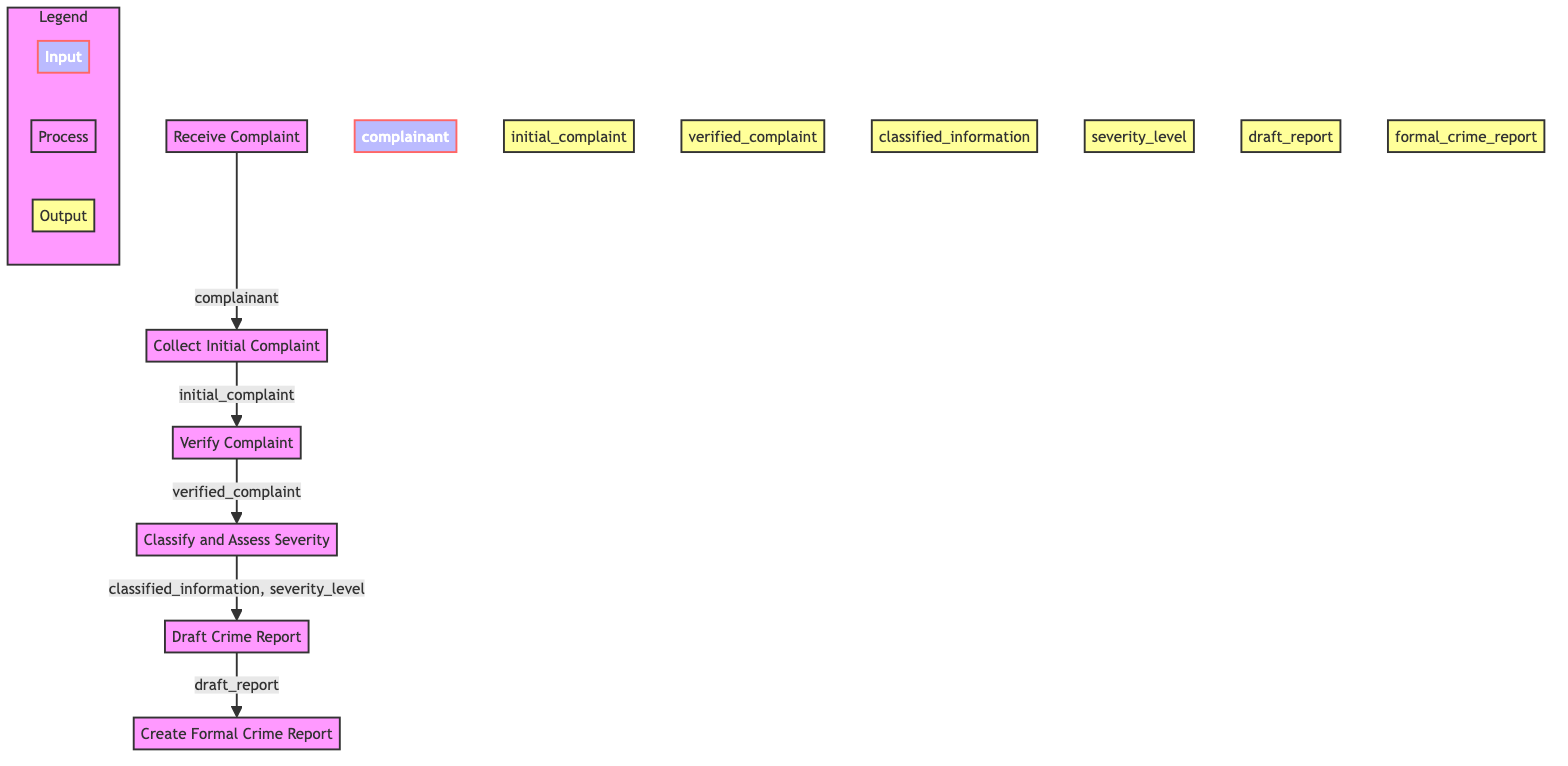What is the first step in the crime report filing procedure? The first step is receiving the complaint from the public, which initiates the procedure. The starting node in the diagram is labeled "Receive Complaint."
Answer: Receive Complaint How many total process nodes are there in the diagram? The process nodes are 'Receive Complaint', 'Collect Initial Complaint', 'Verify Complaint', 'Classify and Assess Severity', 'Draft Crime Report', and 'Create Formal Crime Report.' Counting these, there are six process nodes in total.
Answer: 6 What is the input for the 'Verify Complaint' function? The input to the 'Verify Complaint' function is the 'initial_complaint' output from the 'Collect Initial Complaint' node.
Answer: initial_complaint What outputs does the 'Classify and Assess Severity' function produce? The function 'Classify and Assess Severity' produces 'classified_information' and 'severity_level' as outputs, as indicated by the arrows pointing from this node.
Answer: classified_information, severity_level What is the final output of the crime report filing procedure? The last step in the diagram is the 'Create Formal Crime Report' function, which produces 'formal_crime_report' as the final output of the entire procedure.
Answer: formal_crime_report Which function does the 'initial_complaint' serve as an output for? The 'initial_complaint' is an output from the 'Collect Initial Complaint' function, which directly follows 'Receive Complaint.'
Answer: Collect Initial Complaint How do 'draft_report' and 'formal_crime_report' relate to each other in the flowchart? 'draft_report' is the output of the 'Draft Crime Report' function, and it serves as an input to the 'Create Formal Crime Report' function, linking them in the sequential process.
Answer: Draft Crime Report, Create Formal Crime Report What stage must a complaint go through after it is verified? Once a complaint is verified, it progresses to the classification and severity assessment stage, following the 'Verify Complaint' function in the diagram.
Answer: Classify and Assess Severity 